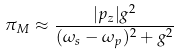<formula> <loc_0><loc_0><loc_500><loc_500>\pi _ { M } \approx \frac { | p _ { z } | g ^ { 2 } } { ( \omega _ { s } - \omega _ { p } ) ^ { 2 } + g ^ { 2 } }</formula> 